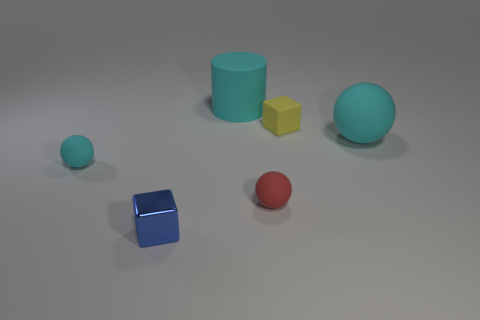Add 2 small cyan objects. How many objects exist? 8 Subtract all cylinders. How many objects are left? 5 Add 1 big yellow shiny spheres. How many big yellow shiny spheres exist? 1 Subtract 0 gray balls. How many objects are left? 6 Subtract all small cyan balls. Subtract all tiny yellow cubes. How many objects are left? 4 Add 4 tiny blue metallic cubes. How many tiny blue metallic cubes are left? 5 